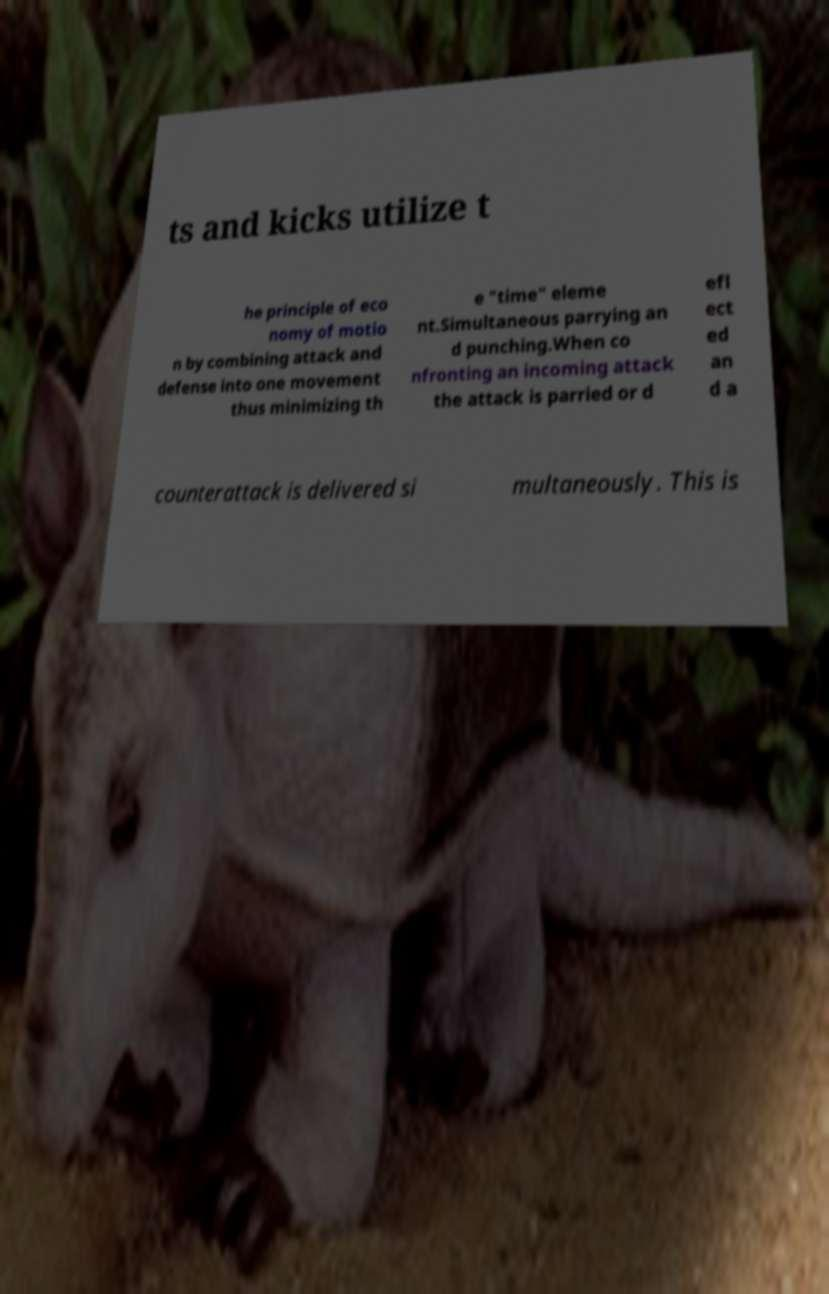What messages or text are displayed in this image? I need them in a readable, typed format. ts and kicks utilize t he principle of eco nomy of motio n by combining attack and defense into one movement thus minimizing th e "time" eleme nt.Simultaneous parrying an d punching.When co nfronting an incoming attack the attack is parried or d efl ect ed an d a counterattack is delivered si multaneously. This is 